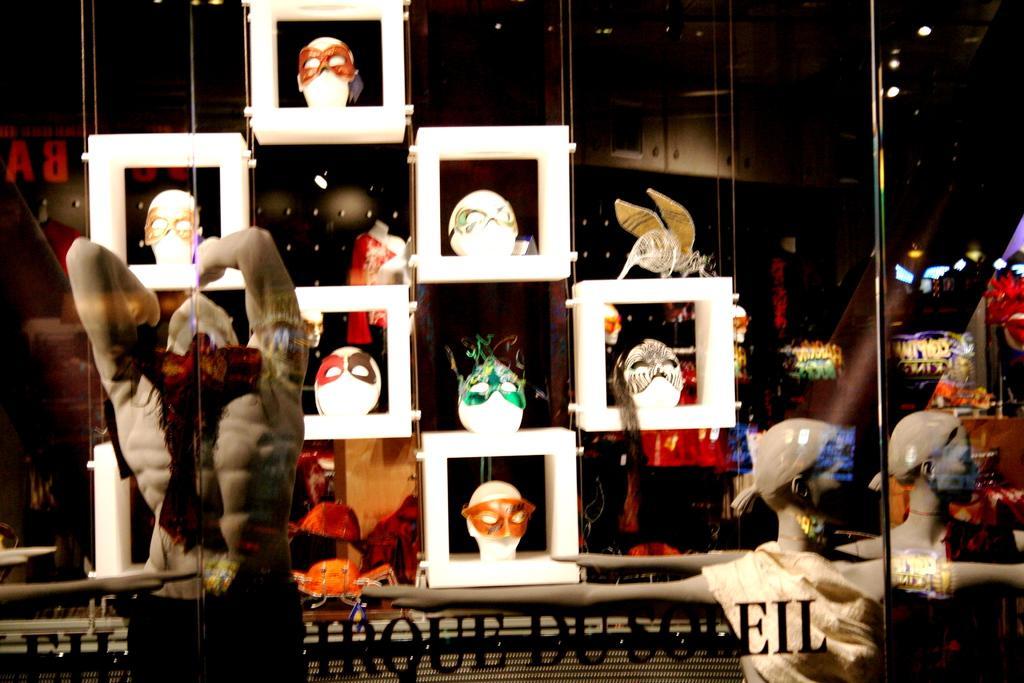In one or two sentences, can you explain what this image depicts? In this image we can see some masks on the heads of the mannequins, which are on the racks, there are other mannequins, there are lights, also we can see the text on the glass wall. 